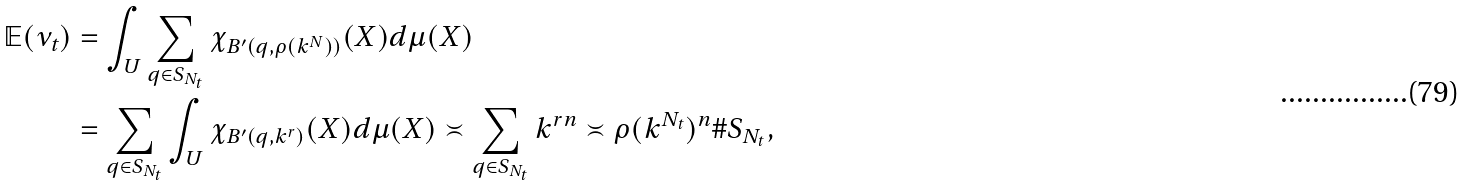Convert formula to latex. <formula><loc_0><loc_0><loc_500><loc_500>\mathbb { E } ( \nu _ { t } ) & = \int _ { U } \sum _ { q \in S _ { N _ { t } } } \chi _ { B ^ { \prime } ( q , \rho ( k ^ { N } ) ) } ( X ) d \mu ( X ) \\ & = \sum _ { q \in S _ { N _ { t } } } \int _ { U } \chi _ { B ^ { \prime } ( q , k ^ { r } ) } ( X ) d \mu ( X ) \asymp \sum _ { q \in S _ { N _ { t } } } k ^ { r n } \asymp \rho ( k ^ { N _ { t } } ) ^ { n } \# S _ { N _ { t } } ,</formula> 